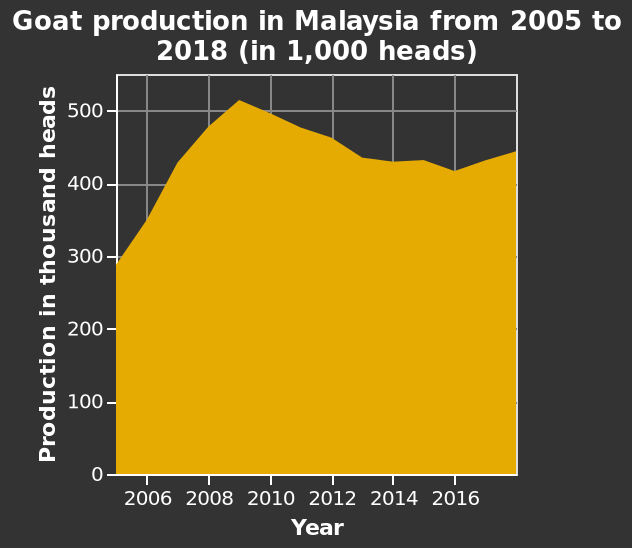<image>
please summary the statistics and relations of the chart 2009 showed the most amount of goats with over 500,000 heads, 2005 saw the least with under 300,000 heads. Between 2012 and 2015 the graph has remained pretty consistent between 400,000 to 500,000. How long did it take for production to decline? Production declined slowly over a period of 7 years, from 2009 to 2016. Describe the following image in detail Here a is a area plot named Goat production in Malaysia from 2005 to 2018 (in 1,000 heads). The x-axis plots Year while the y-axis plots Production in thousand heads. 